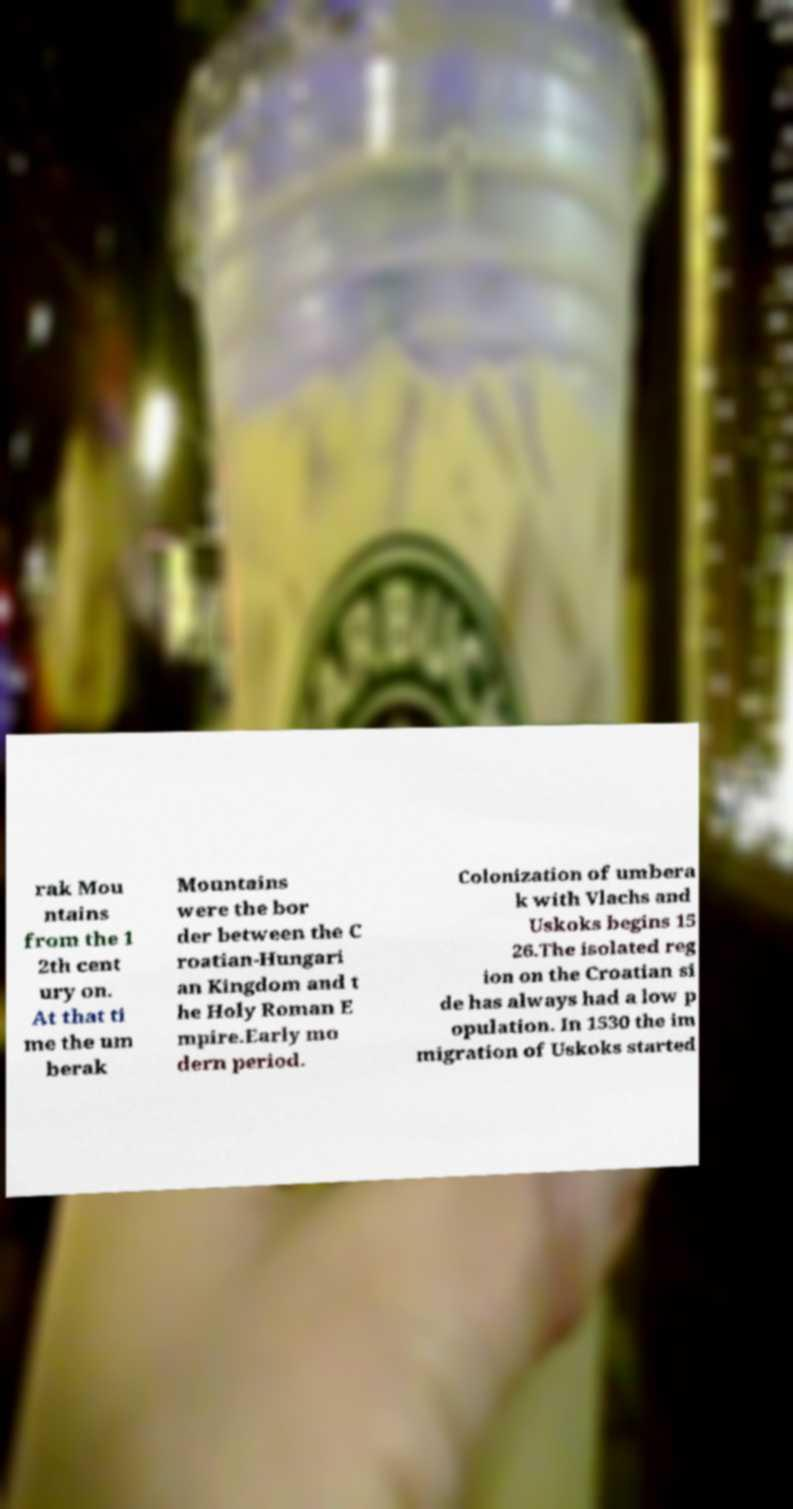I need the written content from this picture converted into text. Can you do that? rak Mou ntains from the 1 2th cent ury on. At that ti me the um berak Mountains were the bor der between the C roatian-Hungari an Kingdom and t he Holy Roman E mpire.Early mo dern period. Colonization of umbera k with Vlachs and Uskoks begins 15 26.The isolated reg ion on the Croatian si de has always had a low p opulation. In 1530 the im migration of Uskoks started 